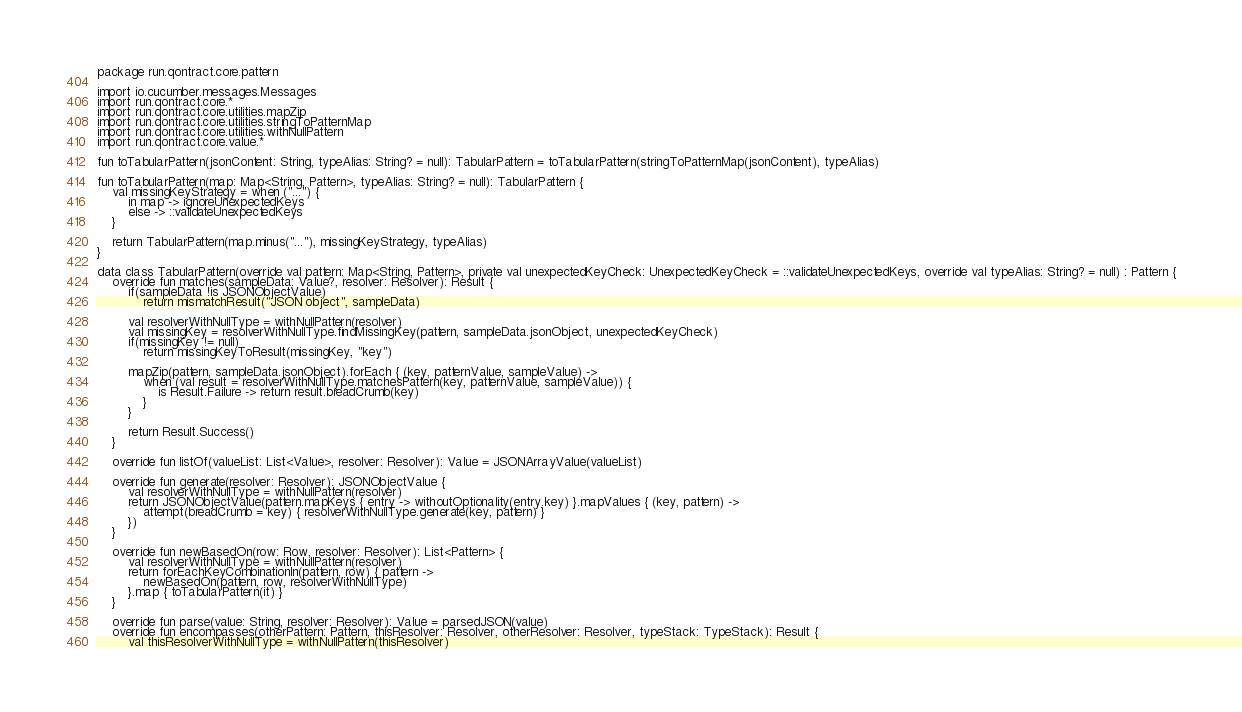<code> <loc_0><loc_0><loc_500><loc_500><_Kotlin_>package run.qontract.core.pattern

import io.cucumber.messages.Messages
import run.qontract.core.*
import run.qontract.core.utilities.mapZip
import run.qontract.core.utilities.stringToPatternMap
import run.qontract.core.utilities.withNullPattern
import run.qontract.core.value.*

fun toTabularPattern(jsonContent: String, typeAlias: String? = null): TabularPattern = toTabularPattern(stringToPatternMap(jsonContent), typeAlias)

fun toTabularPattern(map: Map<String, Pattern>, typeAlias: String? = null): TabularPattern {
    val missingKeyStrategy = when ("...") {
        in map -> ignoreUnexpectedKeys
        else -> ::validateUnexpectedKeys
    }

    return TabularPattern(map.minus("..."), missingKeyStrategy, typeAlias)
}

data class TabularPattern(override val pattern: Map<String, Pattern>, private val unexpectedKeyCheck: UnexpectedKeyCheck = ::validateUnexpectedKeys, override val typeAlias: String? = null) : Pattern {
    override fun matches(sampleData: Value?, resolver: Resolver): Result {
        if(sampleData !is JSONObjectValue)
            return mismatchResult("JSON object", sampleData)

        val resolverWithNullType = withNullPattern(resolver)
        val missingKey = resolverWithNullType.findMissingKey(pattern, sampleData.jsonObject, unexpectedKeyCheck)
        if(missingKey != null)
            return missingKeyToResult(missingKey, "key")

        mapZip(pattern, sampleData.jsonObject).forEach { (key, patternValue, sampleValue) ->
            when (val result = resolverWithNullType.matchesPattern(key, patternValue, sampleValue)) {
                is Result.Failure -> return result.breadCrumb(key)
            }
        }

        return Result.Success()
    }

    override fun listOf(valueList: List<Value>, resolver: Resolver): Value = JSONArrayValue(valueList)

    override fun generate(resolver: Resolver): JSONObjectValue {
        val resolverWithNullType = withNullPattern(resolver)
        return JSONObjectValue(pattern.mapKeys { entry -> withoutOptionality(entry.key) }.mapValues { (key, pattern) ->
            attempt(breadCrumb = key) { resolverWithNullType.generate(key, pattern) }
        })
    }

    override fun newBasedOn(row: Row, resolver: Resolver): List<Pattern> {
        val resolverWithNullType = withNullPattern(resolver)
        return forEachKeyCombinationIn(pattern, row) { pattern ->
            newBasedOn(pattern, row, resolverWithNullType)
        }.map { toTabularPattern(it) }
    }

    override fun parse(value: String, resolver: Resolver): Value = parsedJSON(value)
    override fun encompasses(otherPattern: Pattern, thisResolver: Resolver, otherResolver: Resolver, typeStack: TypeStack): Result {
        val thisResolverWithNullType = withNullPattern(thisResolver)</code> 